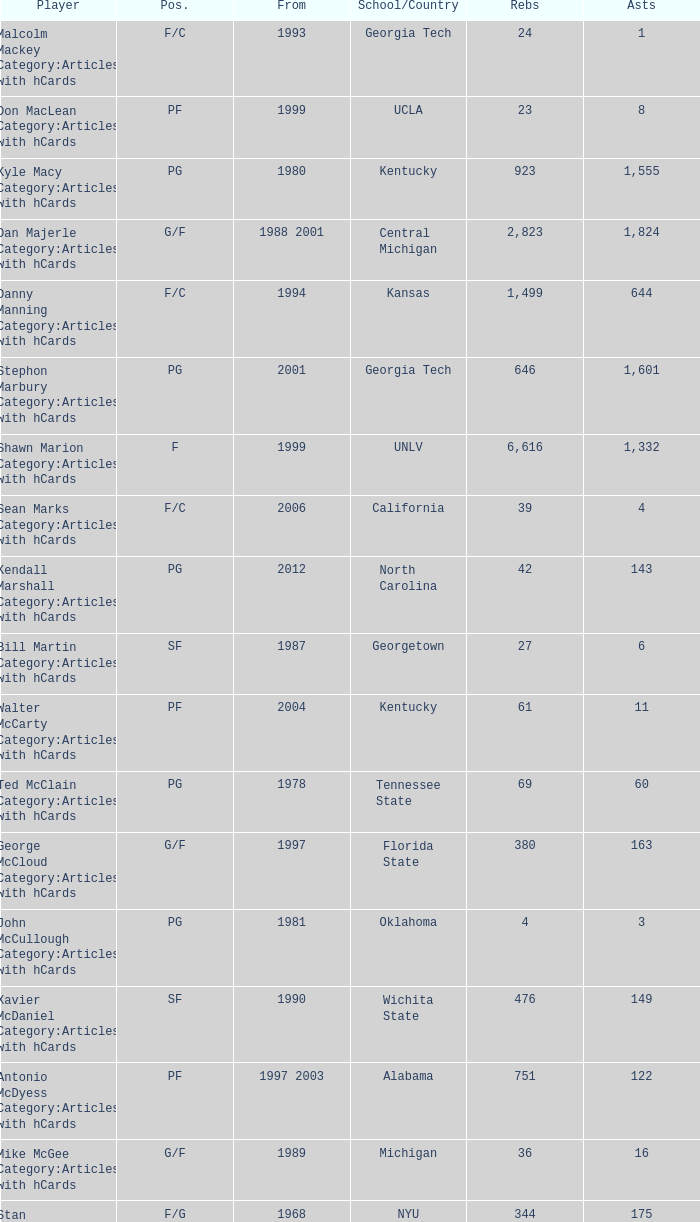Help me parse the entirety of this table. {'header': ['Player', 'Pos.', 'From', 'School/Country', 'Rebs', 'Asts'], 'rows': [['Malcolm Mackey Category:Articles with hCards', 'F/C', '1993', 'Georgia Tech', '24', '1'], ['Don MacLean Category:Articles with hCards', 'PF', '1999', 'UCLA', '23', '8'], ['Kyle Macy Category:Articles with hCards', 'PG', '1980', 'Kentucky', '923', '1,555'], ['Dan Majerle Category:Articles with hCards', 'G/F', '1988 2001', 'Central Michigan', '2,823', '1,824'], ['Danny Manning Category:Articles with hCards', 'F/C', '1994', 'Kansas', '1,499', '644'], ['Stephon Marbury Category:Articles with hCards', 'PG', '2001', 'Georgia Tech', '646', '1,601'], ['Shawn Marion Category:Articles with hCards', 'F', '1999', 'UNLV', '6,616', '1,332'], ['Sean Marks Category:Articles with hCards', 'F/C', '2006', 'California', '39', '4'], ['Kendall Marshall Category:Articles with hCards', 'PG', '2012', 'North Carolina', '42', '143'], ['Bill Martin Category:Articles with hCards', 'SF', '1987', 'Georgetown', '27', '6'], ['Walter McCarty Category:Articles with hCards', 'PF', '2004', 'Kentucky', '61', '11'], ['Ted McClain Category:Articles with hCards', 'PG', '1978', 'Tennessee State', '69', '60'], ['George McCloud Category:Articles with hCards', 'G/F', '1997', 'Florida State', '380', '163'], ['John McCullough Category:Articles with hCards', 'PG', '1981', 'Oklahoma', '4', '3'], ['Xavier McDaniel Category:Articles with hCards', 'SF', '1990', 'Wichita State', '476', '149'], ['Antonio McDyess Category:Articles with hCards', 'PF', '1997 2003', 'Alabama', '751', '122'], ['Mike McGee Category:Articles with hCards', 'G/F', '1989', 'Michigan', '36', '16'], ['Stan McKenzie Category:Articles with hCards', 'F/G', '1968', 'NYU', '344', '175'], ['McCoy McLemore Category:Articles with hCards', 'F/C', '1968', 'Drake', '168', '50'], ['Paul McPherson Category:Articles with hCards', 'SG', '2000', 'DePaul', '48', '16'], ['Gary Melchionni Category:Articles with hCards', 'PG', '1973', 'Duke', '329', '298'], ['Loren Meyer Category:Articles with hCards', 'C', '1996', 'Iowa State', '96', '12'], ['Marko Milič Category:Articles with hCards', 'G/F', '1997', 'Slovenia', '30', '14'], ['Oliver Miller Category:Articles with hCards', 'C', '1992 1999', 'Arkansas', '1,012', '430'], ['Otto Moore Category:Articles with hCards', 'C/F', '1971', 'Texas Pan–Am', '540', '88'], ['Ron Moore Category:Articles with hCards', 'C', '1987', 'West Virginia State', '6', '0'], ['Chris Morris Category:Articles with hCards', 'SF', '1998', 'Auburn', '121', '23'], ['Marcus Morris Category:Articles with hCards', 'F', '2013', 'Kansas', '66', '16'], ['Markieff Morris Category:Articles with hCards', 'PF', '2011', 'Kansas', '681', '174'], ['Mike Morrison Category:Articles with hCards', 'G', '1989', 'Loyola Maryland', '20', '11'], ['Jerrod Mustaf Category:Articles with hCards', 'F/C', '1991', 'Maryland', '283', '63']]} In what capacity does the player hailing from arkansas participate? C. 